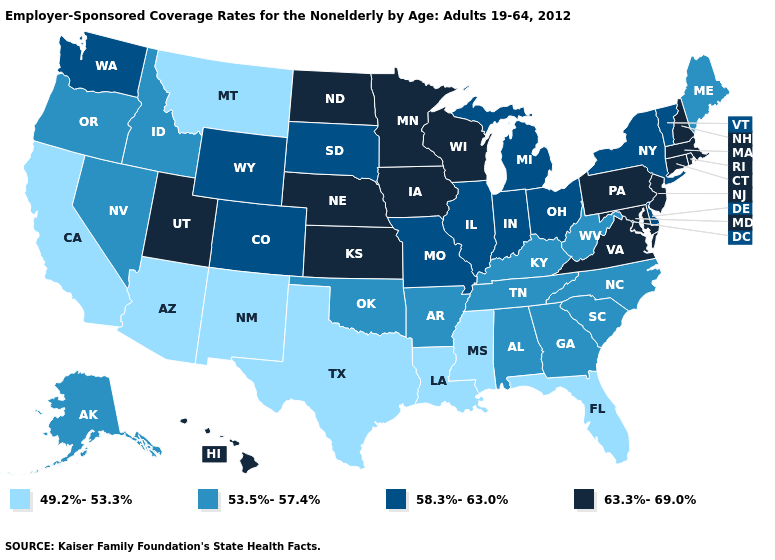Does Washington have the highest value in the USA?
Short answer required. No. Which states have the highest value in the USA?
Quick response, please. Connecticut, Hawaii, Iowa, Kansas, Maryland, Massachusetts, Minnesota, Nebraska, New Hampshire, New Jersey, North Dakota, Pennsylvania, Rhode Island, Utah, Virginia, Wisconsin. Is the legend a continuous bar?
Give a very brief answer. No. Among the states that border Arkansas , which have the highest value?
Be succinct. Missouri. What is the highest value in the West ?
Give a very brief answer. 63.3%-69.0%. Does Minnesota have the highest value in the USA?
Concise answer only. Yes. Name the states that have a value in the range 63.3%-69.0%?
Be succinct. Connecticut, Hawaii, Iowa, Kansas, Maryland, Massachusetts, Minnesota, Nebraska, New Hampshire, New Jersey, North Dakota, Pennsylvania, Rhode Island, Utah, Virginia, Wisconsin. What is the highest value in states that border Massachusetts?
Give a very brief answer. 63.3%-69.0%. Among the states that border Delaware , which have the lowest value?
Write a very short answer. Maryland, New Jersey, Pennsylvania. Does New Hampshire have the same value as Connecticut?
Be succinct. Yes. What is the lowest value in the USA?
Short answer required. 49.2%-53.3%. Among the states that border Louisiana , does Mississippi have the lowest value?
Be succinct. Yes. Does Alaska have the lowest value in the USA?
Write a very short answer. No. Does the first symbol in the legend represent the smallest category?
Quick response, please. Yes. 